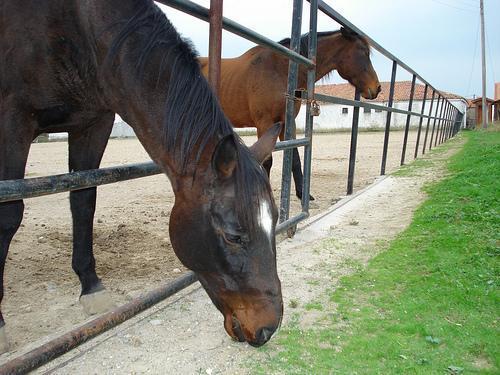How many horses are there?
Give a very brief answer. 2. How many horses are in the photo?
Give a very brief answer. 2. 